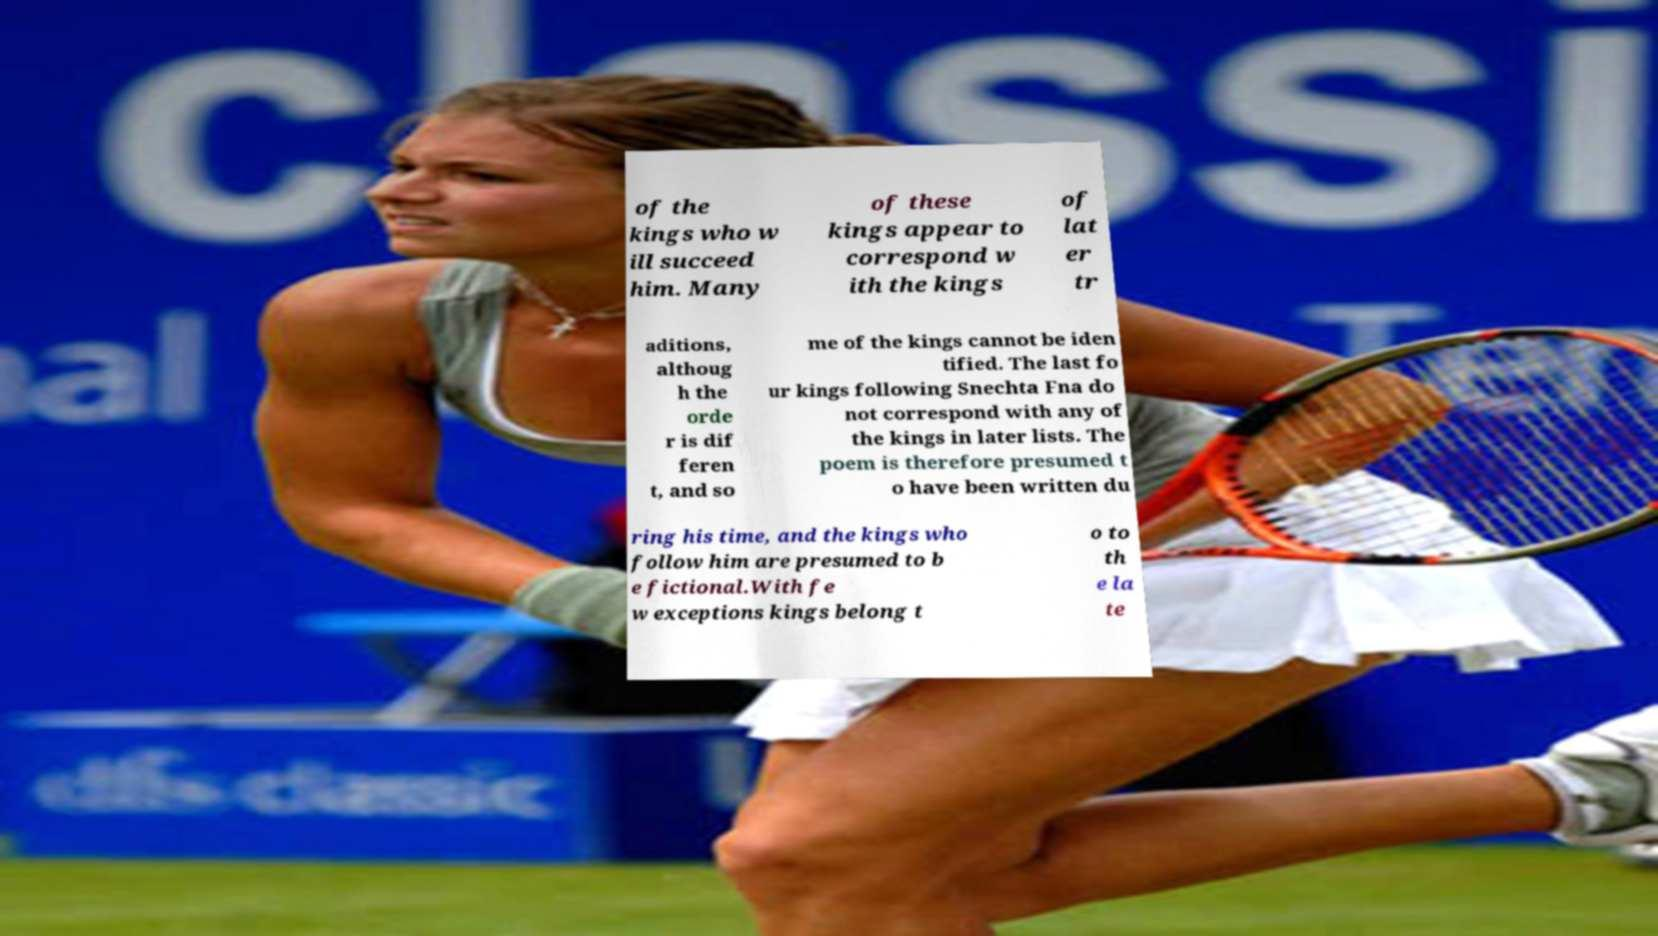Can you accurately transcribe the text from the provided image for me? of the kings who w ill succeed him. Many of these kings appear to correspond w ith the kings of lat er tr aditions, althoug h the orde r is dif feren t, and so me of the kings cannot be iden tified. The last fo ur kings following Snechta Fna do not correspond with any of the kings in later lists. The poem is therefore presumed t o have been written du ring his time, and the kings who follow him are presumed to b e fictional.With fe w exceptions kings belong t o to th e la te 